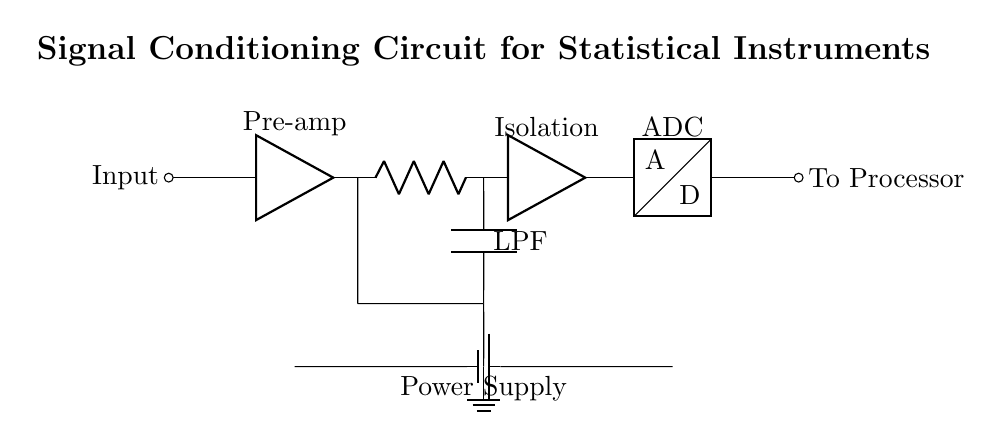What is the main purpose of the circuit? The primary function of this circuit is signal conditioning, which enhances the measurement accuracy in statistical instruments by processing the input signal through various components.
Answer: Signal conditioning What component follows the pre-amplifier? The component that comes right after the pre-amplifier in the circuit is the low-pass filter, which helps to remove high-frequency noise from the signal.
Answer: Low-pass filter How many amplifiers are present in the circuit? There are two amplifiers in this circuit: one is the pre-amplifier, and the other is the isolation amplifier that follows the low-pass filter.
Answer: Two What role does the ADC play in the circuit? The ADC, or Analog-to-Digital Converter, transforms the analog signal from the isolation amplifier into a digital signal for processing, which is essential for statistical analysis.
Answer: Conversion to digital What is the supply voltage in this circuit? The circuit is powered by a battery, but the exact voltage isn't specified in the diagram; it represents power supply functionality in the circuit context.
Answer: Power supply What does LPF stand for in this circuit? In this circuit, LPF stands for Low-Pass Filter, which is a critical component used to improve signal integrity by allowing only low-frequency signals to pass through while attenuating higher frequencies.
Answer: Low-Pass Filter 